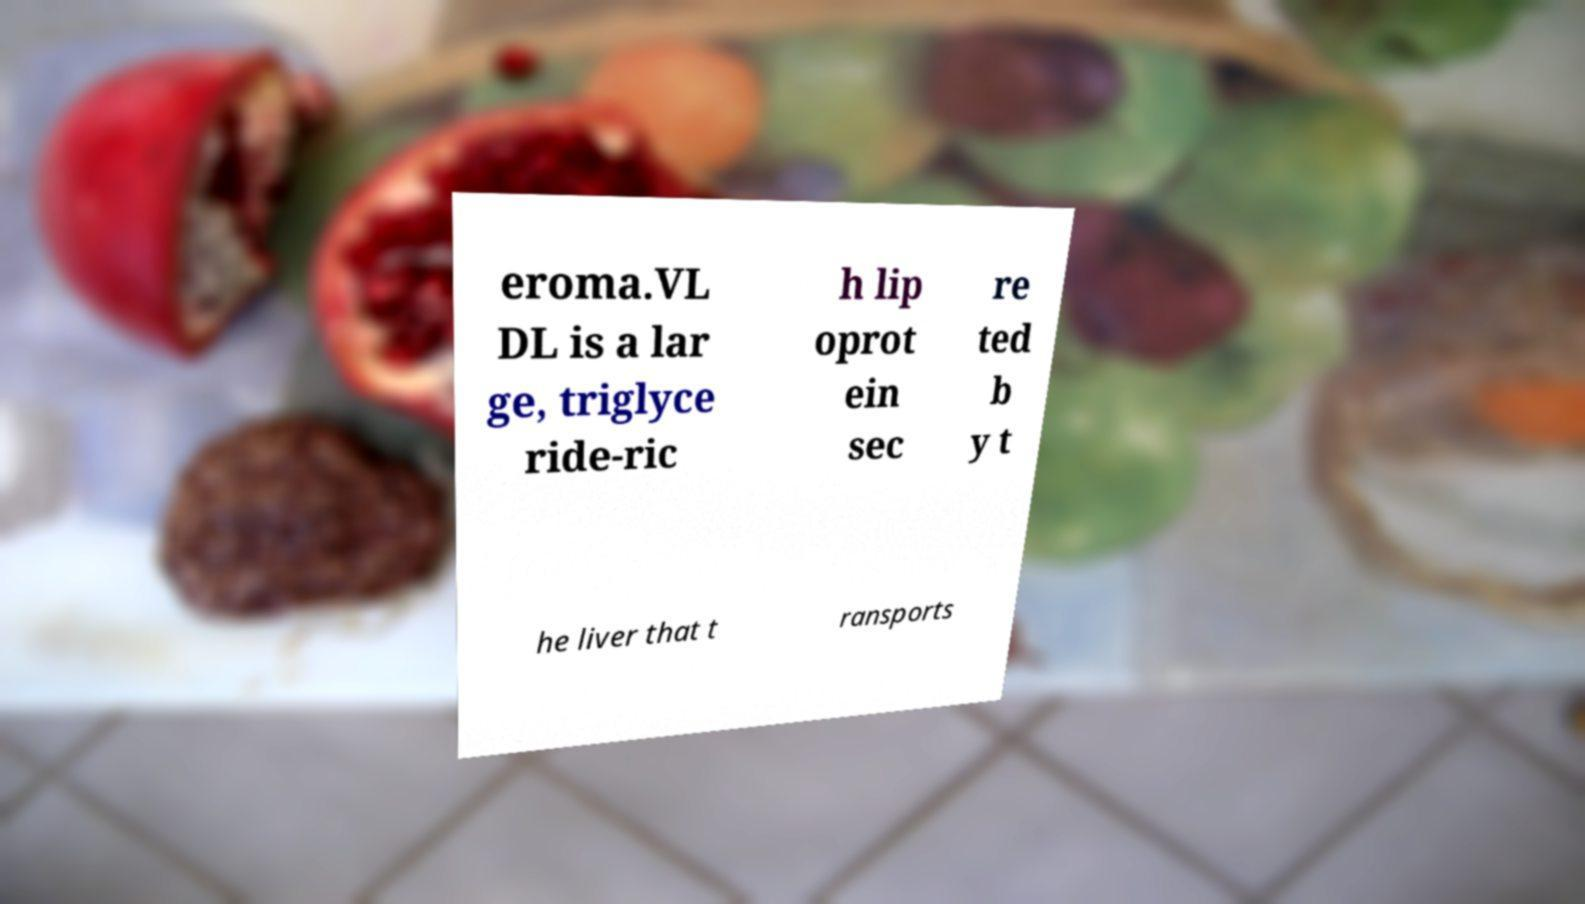Can you read and provide the text displayed in the image?This photo seems to have some interesting text. Can you extract and type it out for me? eroma.VL DL is a lar ge, triglyce ride-ric h lip oprot ein sec re ted b y t he liver that t ransports 